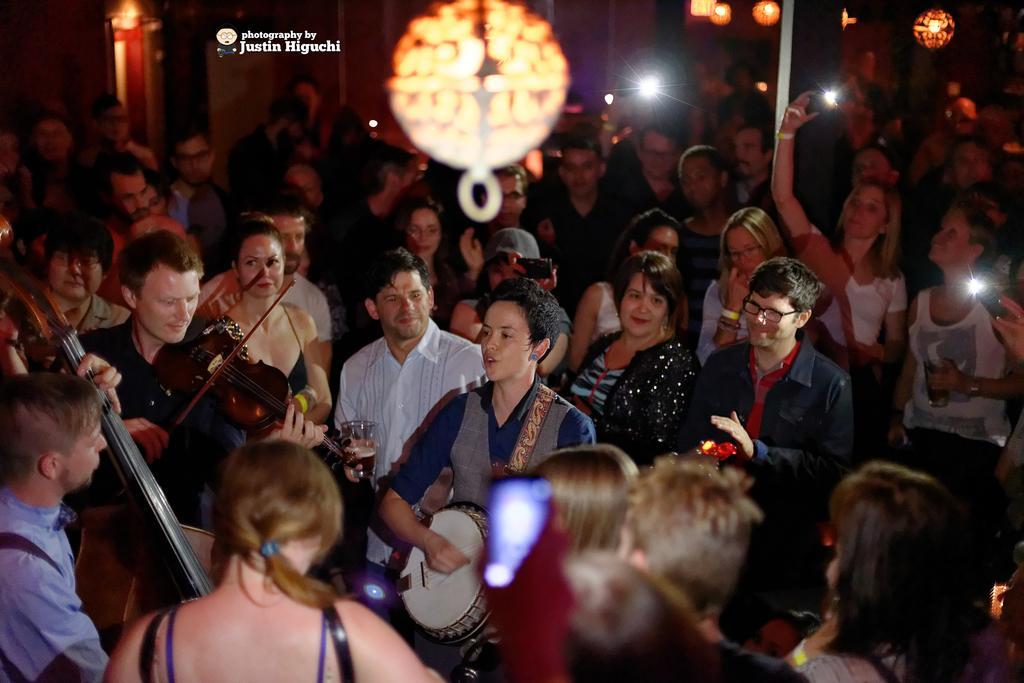Could you give a brief overview of what you see in this image? In this picture we can see a group of people, musical instruments, mobiles and glasses. In the background we can see the lights, walls and some text. 